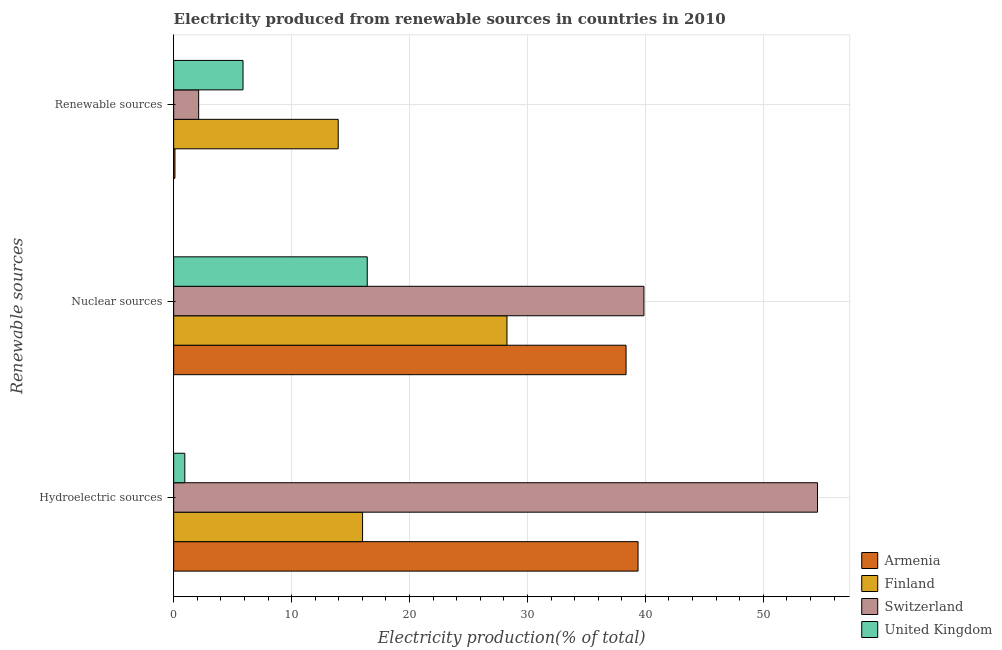How many groups of bars are there?
Offer a very short reply. 3. Are the number of bars on each tick of the Y-axis equal?
Keep it short and to the point. Yes. How many bars are there on the 2nd tick from the top?
Provide a succinct answer. 4. What is the label of the 2nd group of bars from the top?
Provide a short and direct response. Nuclear sources. What is the percentage of electricity produced by hydroelectric sources in Switzerland?
Your answer should be compact. 54.6. Across all countries, what is the maximum percentage of electricity produced by nuclear sources?
Make the answer very short. 39.88. Across all countries, what is the minimum percentage of electricity produced by hydroelectric sources?
Provide a succinct answer. 0.94. In which country was the percentage of electricity produced by hydroelectric sources maximum?
Keep it short and to the point. Switzerland. In which country was the percentage of electricity produced by renewable sources minimum?
Give a very brief answer. Armenia. What is the total percentage of electricity produced by renewable sources in the graph?
Keep it short and to the point. 22.06. What is the difference between the percentage of electricity produced by nuclear sources in Finland and that in Switzerland?
Provide a succinct answer. -11.61. What is the difference between the percentage of electricity produced by hydroelectric sources in Armenia and the percentage of electricity produced by nuclear sources in Switzerland?
Provide a succinct answer. -0.5. What is the average percentage of electricity produced by hydroelectric sources per country?
Your answer should be very brief. 27.73. What is the difference between the percentage of electricity produced by hydroelectric sources and percentage of electricity produced by renewable sources in Switzerland?
Give a very brief answer. 52.48. What is the ratio of the percentage of electricity produced by nuclear sources in Armenia to that in United Kingdom?
Provide a succinct answer. 2.34. What is the difference between the highest and the second highest percentage of electricity produced by hydroelectric sources?
Provide a short and direct response. 15.22. What is the difference between the highest and the lowest percentage of electricity produced by nuclear sources?
Your answer should be compact. 23.46. Is the sum of the percentage of electricity produced by hydroelectric sources in United Kingdom and Finland greater than the maximum percentage of electricity produced by nuclear sources across all countries?
Ensure brevity in your answer.  No. What does the 3rd bar from the top in Renewable sources represents?
Offer a very short reply. Finland. What does the 3rd bar from the bottom in Nuclear sources represents?
Offer a terse response. Switzerland. How many bars are there?
Offer a terse response. 12. Where does the legend appear in the graph?
Provide a short and direct response. Bottom right. How are the legend labels stacked?
Provide a succinct answer. Vertical. What is the title of the graph?
Your response must be concise. Electricity produced from renewable sources in countries in 2010. What is the label or title of the Y-axis?
Make the answer very short. Renewable sources. What is the Electricity production(% of total) in Armenia in Hydroelectric sources?
Your response must be concise. 39.38. What is the Electricity production(% of total) of Finland in Hydroelectric sources?
Keep it short and to the point. 16.02. What is the Electricity production(% of total) of Switzerland in Hydroelectric sources?
Give a very brief answer. 54.6. What is the Electricity production(% of total) of United Kingdom in Hydroelectric sources?
Make the answer very short. 0.94. What is the Electricity production(% of total) in Armenia in Nuclear sources?
Offer a terse response. 38.36. What is the Electricity production(% of total) of Finland in Nuclear sources?
Make the answer very short. 28.26. What is the Electricity production(% of total) in Switzerland in Nuclear sources?
Offer a terse response. 39.88. What is the Electricity production(% of total) in United Kingdom in Nuclear sources?
Give a very brief answer. 16.41. What is the Electricity production(% of total) in Armenia in Renewable sources?
Your answer should be very brief. 0.11. What is the Electricity production(% of total) of Finland in Renewable sources?
Offer a terse response. 13.95. What is the Electricity production(% of total) in Switzerland in Renewable sources?
Your answer should be compact. 2.12. What is the Electricity production(% of total) of United Kingdom in Renewable sources?
Your answer should be very brief. 5.88. Across all Renewable sources, what is the maximum Electricity production(% of total) in Armenia?
Ensure brevity in your answer.  39.38. Across all Renewable sources, what is the maximum Electricity production(% of total) in Finland?
Provide a succinct answer. 28.26. Across all Renewable sources, what is the maximum Electricity production(% of total) of Switzerland?
Offer a very short reply. 54.6. Across all Renewable sources, what is the maximum Electricity production(% of total) in United Kingdom?
Ensure brevity in your answer.  16.41. Across all Renewable sources, what is the minimum Electricity production(% of total) of Armenia?
Provide a short and direct response. 0.11. Across all Renewable sources, what is the minimum Electricity production(% of total) in Finland?
Your response must be concise. 13.95. Across all Renewable sources, what is the minimum Electricity production(% of total) of Switzerland?
Keep it short and to the point. 2.12. Across all Renewable sources, what is the minimum Electricity production(% of total) in United Kingdom?
Offer a terse response. 0.94. What is the total Electricity production(% of total) in Armenia in the graph?
Your response must be concise. 77.85. What is the total Electricity production(% of total) in Finland in the graph?
Offer a terse response. 58.24. What is the total Electricity production(% of total) in Switzerland in the graph?
Make the answer very short. 96.59. What is the total Electricity production(% of total) of United Kingdom in the graph?
Your answer should be very brief. 23.24. What is the difference between the Electricity production(% of total) in Armenia in Hydroelectric sources and that in Nuclear sources?
Provide a succinct answer. 1.02. What is the difference between the Electricity production(% of total) in Finland in Hydroelectric sources and that in Nuclear sources?
Your answer should be compact. -12.25. What is the difference between the Electricity production(% of total) in Switzerland in Hydroelectric sources and that in Nuclear sources?
Ensure brevity in your answer.  14.72. What is the difference between the Electricity production(% of total) of United Kingdom in Hydroelectric sources and that in Nuclear sources?
Offer a terse response. -15.47. What is the difference between the Electricity production(% of total) in Armenia in Hydroelectric sources and that in Renewable sources?
Your response must be concise. 39.27. What is the difference between the Electricity production(% of total) of Finland in Hydroelectric sources and that in Renewable sources?
Make the answer very short. 2.07. What is the difference between the Electricity production(% of total) in Switzerland in Hydroelectric sources and that in Renewable sources?
Keep it short and to the point. 52.48. What is the difference between the Electricity production(% of total) of United Kingdom in Hydroelectric sources and that in Renewable sources?
Make the answer very short. -4.94. What is the difference between the Electricity production(% of total) of Armenia in Nuclear sources and that in Renewable sources?
Provide a short and direct response. 38.25. What is the difference between the Electricity production(% of total) of Finland in Nuclear sources and that in Renewable sources?
Your response must be concise. 14.31. What is the difference between the Electricity production(% of total) in Switzerland in Nuclear sources and that in Renewable sources?
Keep it short and to the point. 37.76. What is the difference between the Electricity production(% of total) of United Kingdom in Nuclear sources and that in Renewable sources?
Make the answer very short. 10.53. What is the difference between the Electricity production(% of total) of Armenia in Hydroelectric sources and the Electricity production(% of total) of Finland in Nuclear sources?
Your response must be concise. 11.11. What is the difference between the Electricity production(% of total) in Armenia in Hydroelectric sources and the Electricity production(% of total) in Switzerland in Nuclear sources?
Provide a short and direct response. -0.5. What is the difference between the Electricity production(% of total) in Armenia in Hydroelectric sources and the Electricity production(% of total) in United Kingdom in Nuclear sources?
Offer a terse response. 22.96. What is the difference between the Electricity production(% of total) in Finland in Hydroelectric sources and the Electricity production(% of total) in Switzerland in Nuclear sources?
Your answer should be compact. -23.86. What is the difference between the Electricity production(% of total) in Finland in Hydroelectric sources and the Electricity production(% of total) in United Kingdom in Nuclear sources?
Your response must be concise. -0.39. What is the difference between the Electricity production(% of total) of Switzerland in Hydroelectric sources and the Electricity production(% of total) of United Kingdom in Nuclear sources?
Keep it short and to the point. 38.18. What is the difference between the Electricity production(% of total) of Armenia in Hydroelectric sources and the Electricity production(% of total) of Finland in Renewable sources?
Your answer should be very brief. 25.42. What is the difference between the Electricity production(% of total) of Armenia in Hydroelectric sources and the Electricity production(% of total) of Switzerland in Renewable sources?
Your response must be concise. 37.26. What is the difference between the Electricity production(% of total) of Armenia in Hydroelectric sources and the Electricity production(% of total) of United Kingdom in Renewable sources?
Provide a succinct answer. 33.5. What is the difference between the Electricity production(% of total) in Finland in Hydroelectric sources and the Electricity production(% of total) in Switzerland in Renewable sources?
Provide a short and direct response. 13.9. What is the difference between the Electricity production(% of total) in Finland in Hydroelectric sources and the Electricity production(% of total) in United Kingdom in Renewable sources?
Your answer should be very brief. 10.14. What is the difference between the Electricity production(% of total) of Switzerland in Hydroelectric sources and the Electricity production(% of total) of United Kingdom in Renewable sources?
Make the answer very short. 48.72. What is the difference between the Electricity production(% of total) of Armenia in Nuclear sources and the Electricity production(% of total) of Finland in Renewable sources?
Make the answer very short. 24.41. What is the difference between the Electricity production(% of total) in Armenia in Nuclear sources and the Electricity production(% of total) in Switzerland in Renewable sources?
Offer a terse response. 36.24. What is the difference between the Electricity production(% of total) of Armenia in Nuclear sources and the Electricity production(% of total) of United Kingdom in Renewable sources?
Make the answer very short. 32.48. What is the difference between the Electricity production(% of total) of Finland in Nuclear sources and the Electricity production(% of total) of Switzerland in Renewable sources?
Offer a very short reply. 26.15. What is the difference between the Electricity production(% of total) in Finland in Nuclear sources and the Electricity production(% of total) in United Kingdom in Renewable sources?
Provide a short and direct response. 22.38. What is the difference between the Electricity production(% of total) in Switzerland in Nuclear sources and the Electricity production(% of total) in United Kingdom in Renewable sources?
Offer a terse response. 34. What is the average Electricity production(% of total) of Armenia per Renewable sources?
Your answer should be compact. 25.95. What is the average Electricity production(% of total) of Finland per Renewable sources?
Your response must be concise. 19.41. What is the average Electricity production(% of total) of Switzerland per Renewable sources?
Provide a succinct answer. 32.2. What is the average Electricity production(% of total) in United Kingdom per Renewable sources?
Provide a succinct answer. 7.75. What is the difference between the Electricity production(% of total) of Armenia and Electricity production(% of total) of Finland in Hydroelectric sources?
Your response must be concise. 23.36. What is the difference between the Electricity production(% of total) in Armenia and Electricity production(% of total) in Switzerland in Hydroelectric sources?
Keep it short and to the point. -15.22. What is the difference between the Electricity production(% of total) in Armenia and Electricity production(% of total) in United Kingdom in Hydroelectric sources?
Your answer should be very brief. 38.43. What is the difference between the Electricity production(% of total) of Finland and Electricity production(% of total) of Switzerland in Hydroelectric sources?
Provide a succinct answer. -38.58. What is the difference between the Electricity production(% of total) in Finland and Electricity production(% of total) in United Kingdom in Hydroelectric sources?
Offer a very short reply. 15.07. What is the difference between the Electricity production(% of total) in Switzerland and Electricity production(% of total) in United Kingdom in Hydroelectric sources?
Offer a very short reply. 53.65. What is the difference between the Electricity production(% of total) of Armenia and Electricity production(% of total) of Finland in Nuclear sources?
Ensure brevity in your answer.  10.1. What is the difference between the Electricity production(% of total) in Armenia and Electricity production(% of total) in Switzerland in Nuclear sources?
Provide a succinct answer. -1.52. What is the difference between the Electricity production(% of total) of Armenia and Electricity production(% of total) of United Kingdom in Nuclear sources?
Provide a short and direct response. 21.95. What is the difference between the Electricity production(% of total) of Finland and Electricity production(% of total) of Switzerland in Nuclear sources?
Ensure brevity in your answer.  -11.61. What is the difference between the Electricity production(% of total) in Finland and Electricity production(% of total) in United Kingdom in Nuclear sources?
Give a very brief answer. 11.85. What is the difference between the Electricity production(% of total) of Switzerland and Electricity production(% of total) of United Kingdom in Nuclear sources?
Your response must be concise. 23.46. What is the difference between the Electricity production(% of total) in Armenia and Electricity production(% of total) in Finland in Renewable sources?
Your response must be concise. -13.85. What is the difference between the Electricity production(% of total) of Armenia and Electricity production(% of total) of Switzerland in Renewable sources?
Offer a very short reply. -2.01. What is the difference between the Electricity production(% of total) of Armenia and Electricity production(% of total) of United Kingdom in Renewable sources?
Your answer should be compact. -5.77. What is the difference between the Electricity production(% of total) of Finland and Electricity production(% of total) of Switzerland in Renewable sources?
Your answer should be very brief. 11.84. What is the difference between the Electricity production(% of total) of Finland and Electricity production(% of total) of United Kingdom in Renewable sources?
Your answer should be very brief. 8.07. What is the difference between the Electricity production(% of total) in Switzerland and Electricity production(% of total) in United Kingdom in Renewable sources?
Provide a succinct answer. -3.76. What is the ratio of the Electricity production(% of total) in Armenia in Hydroelectric sources to that in Nuclear sources?
Give a very brief answer. 1.03. What is the ratio of the Electricity production(% of total) in Finland in Hydroelectric sources to that in Nuclear sources?
Provide a succinct answer. 0.57. What is the ratio of the Electricity production(% of total) of Switzerland in Hydroelectric sources to that in Nuclear sources?
Make the answer very short. 1.37. What is the ratio of the Electricity production(% of total) in United Kingdom in Hydroelectric sources to that in Nuclear sources?
Make the answer very short. 0.06. What is the ratio of the Electricity production(% of total) in Armenia in Hydroelectric sources to that in Renewable sources?
Provide a short and direct response. 365.14. What is the ratio of the Electricity production(% of total) of Finland in Hydroelectric sources to that in Renewable sources?
Provide a short and direct response. 1.15. What is the ratio of the Electricity production(% of total) in Switzerland in Hydroelectric sources to that in Renewable sources?
Your answer should be compact. 25.78. What is the ratio of the Electricity production(% of total) of United Kingdom in Hydroelectric sources to that in Renewable sources?
Offer a very short reply. 0.16. What is the ratio of the Electricity production(% of total) of Armenia in Nuclear sources to that in Renewable sources?
Keep it short and to the point. 355.71. What is the ratio of the Electricity production(% of total) in Finland in Nuclear sources to that in Renewable sources?
Your answer should be very brief. 2.03. What is the ratio of the Electricity production(% of total) of Switzerland in Nuclear sources to that in Renewable sources?
Ensure brevity in your answer.  18.83. What is the ratio of the Electricity production(% of total) in United Kingdom in Nuclear sources to that in Renewable sources?
Your answer should be very brief. 2.79. What is the difference between the highest and the second highest Electricity production(% of total) of Armenia?
Offer a terse response. 1.02. What is the difference between the highest and the second highest Electricity production(% of total) in Finland?
Your response must be concise. 12.25. What is the difference between the highest and the second highest Electricity production(% of total) in Switzerland?
Offer a terse response. 14.72. What is the difference between the highest and the second highest Electricity production(% of total) in United Kingdom?
Your response must be concise. 10.53. What is the difference between the highest and the lowest Electricity production(% of total) in Armenia?
Make the answer very short. 39.27. What is the difference between the highest and the lowest Electricity production(% of total) in Finland?
Your answer should be very brief. 14.31. What is the difference between the highest and the lowest Electricity production(% of total) of Switzerland?
Provide a short and direct response. 52.48. What is the difference between the highest and the lowest Electricity production(% of total) of United Kingdom?
Keep it short and to the point. 15.47. 